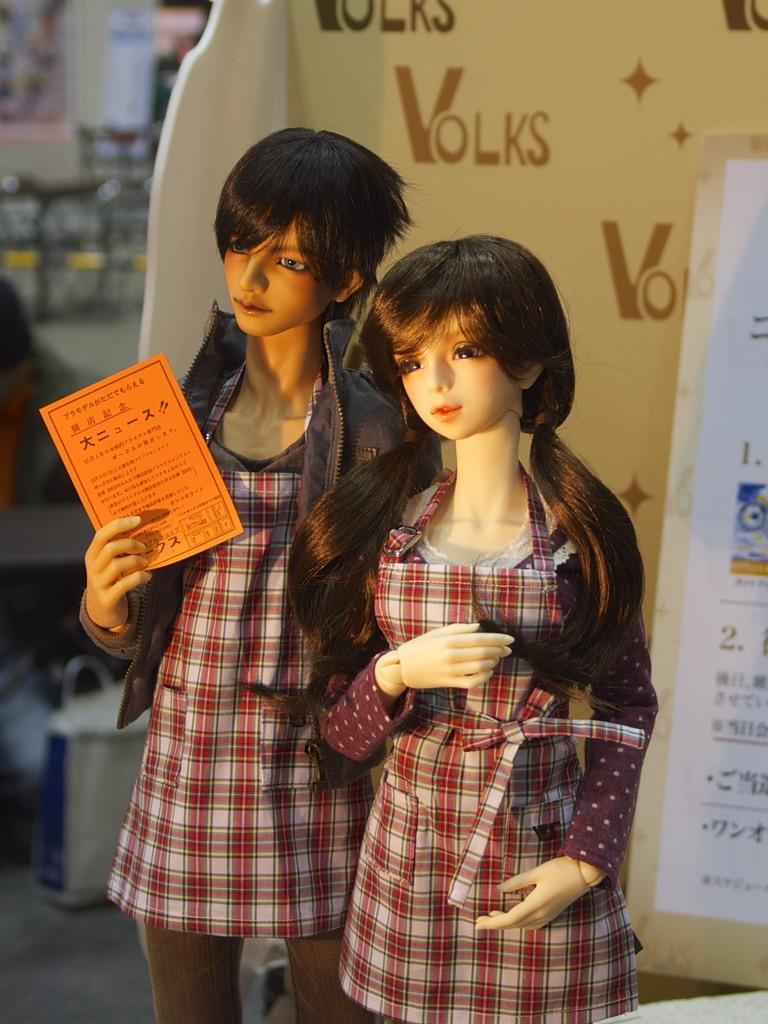How many mannequins are in the image? There are two mannequins in the image. What is one of the mannequins holding? One of the mannequins is holding a paper in its hands. What can be seen in the background of the image? There is a board in the background of the image. Can you read the text on the board? No, the text on the board is blurred and cannot be read. What type of glass is being used to adjust the mannequin's position in the image? There is no glass or adjustment of the mannequin's position visible in the image. 